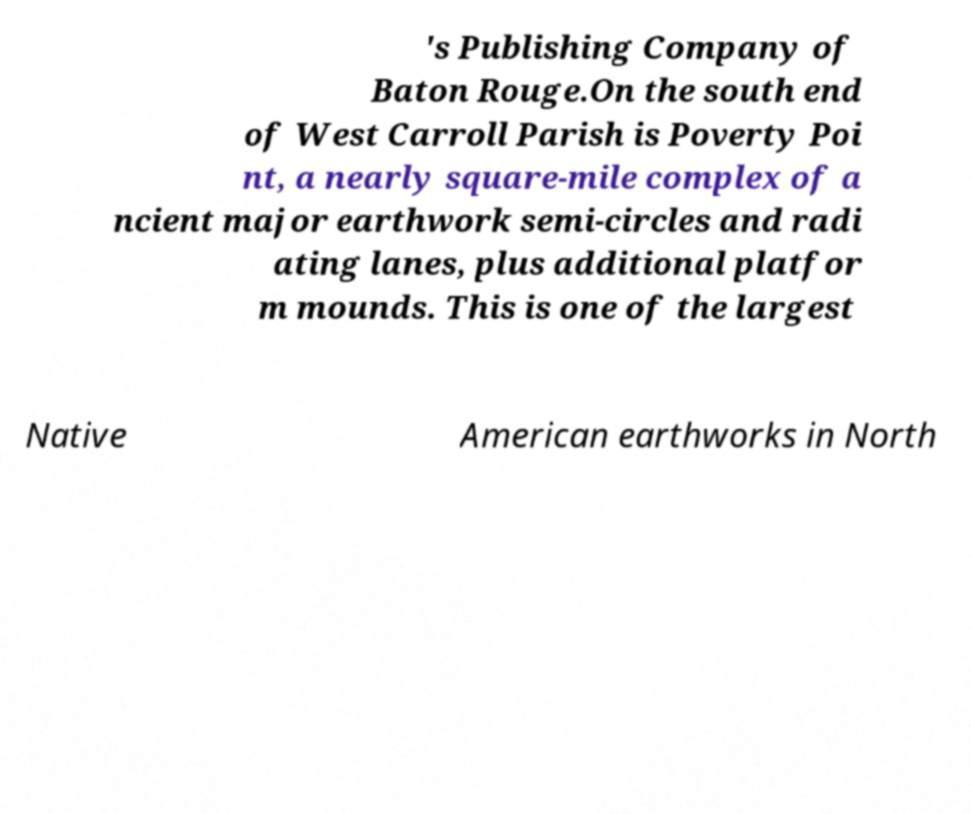Could you extract and type out the text from this image? 's Publishing Company of Baton Rouge.On the south end of West Carroll Parish is Poverty Poi nt, a nearly square-mile complex of a ncient major earthwork semi-circles and radi ating lanes, plus additional platfor m mounds. This is one of the largest Native American earthworks in North 